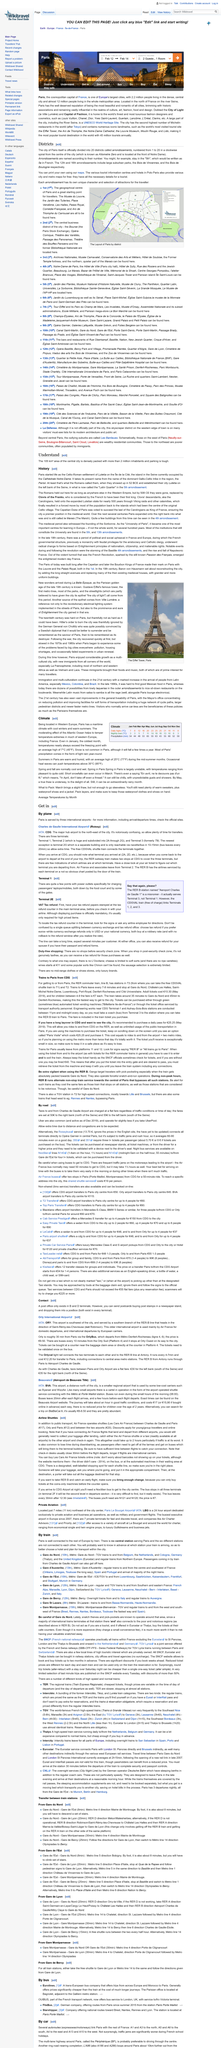Point out several critical features in this image. The precipitation in January is 54 millimeters. The title of this page is "Districts". The page is about Paris. The central city is home to over 2 million people, as it is inhabited by more than 2 million people within its 105 km² area. This page is editable. 